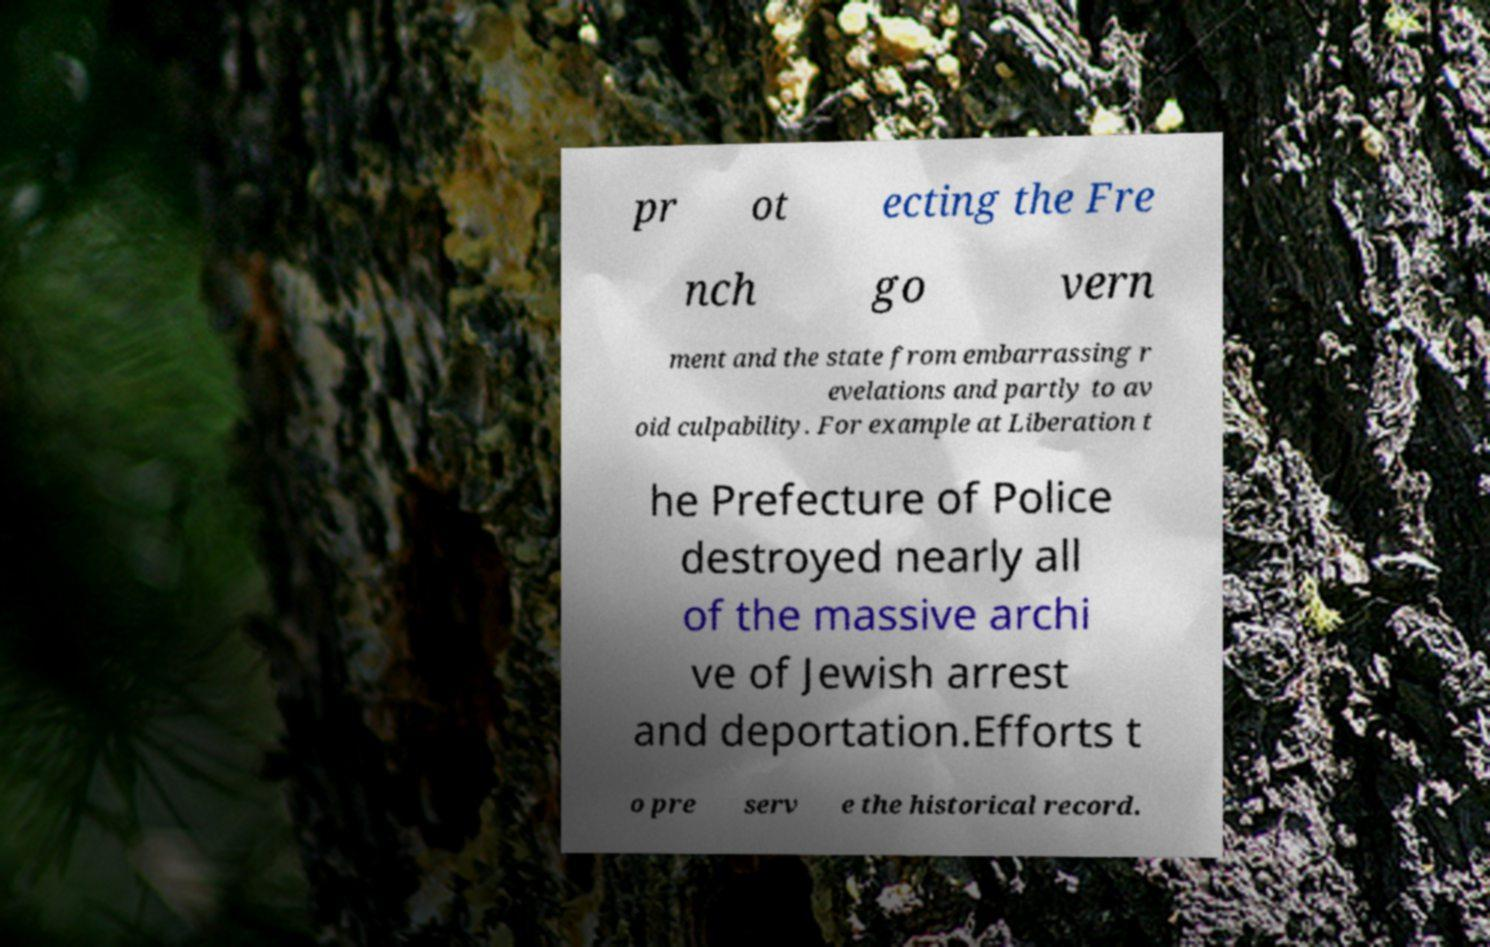There's text embedded in this image that I need extracted. Can you transcribe it verbatim? pr ot ecting the Fre nch go vern ment and the state from embarrassing r evelations and partly to av oid culpability. For example at Liberation t he Prefecture of Police destroyed nearly all of the massive archi ve of Jewish arrest and deportation.Efforts t o pre serv e the historical record. 